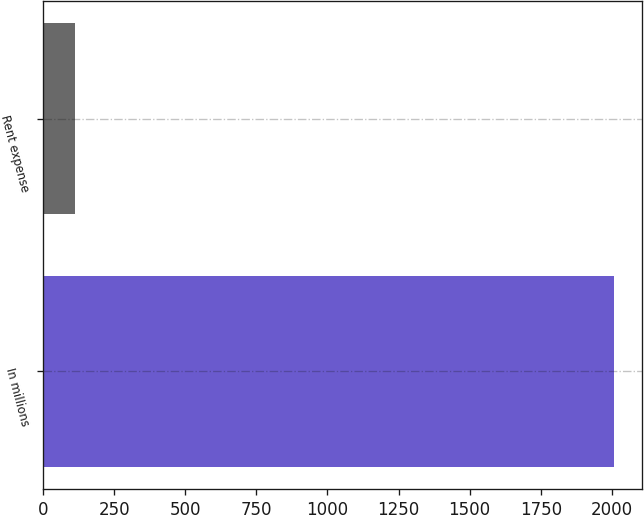Convert chart. <chart><loc_0><loc_0><loc_500><loc_500><bar_chart><fcel>In millions<fcel>Rent expense<nl><fcel>2007<fcel>113<nl></chart> 